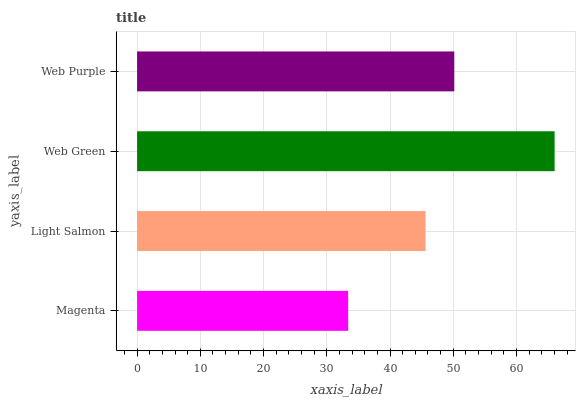Is Magenta the minimum?
Answer yes or no. Yes. Is Web Green the maximum?
Answer yes or no. Yes. Is Light Salmon the minimum?
Answer yes or no. No. Is Light Salmon the maximum?
Answer yes or no. No. Is Light Salmon greater than Magenta?
Answer yes or no. Yes. Is Magenta less than Light Salmon?
Answer yes or no. Yes. Is Magenta greater than Light Salmon?
Answer yes or no. No. Is Light Salmon less than Magenta?
Answer yes or no. No. Is Web Purple the high median?
Answer yes or no. Yes. Is Light Salmon the low median?
Answer yes or no. Yes. Is Web Green the high median?
Answer yes or no. No. Is Web Green the low median?
Answer yes or no. No. 